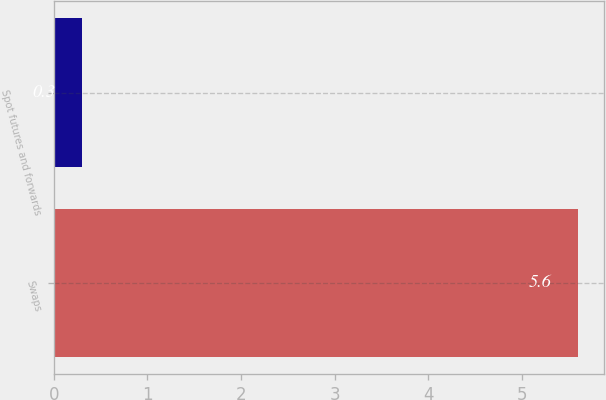<chart> <loc_0><loc_0><loc_500><loc_500><bar_chart><fcel>Swaps<fcel>Spot futures and forwards<nl><fcel>5.6<fcel>0.3<nl></chart> 